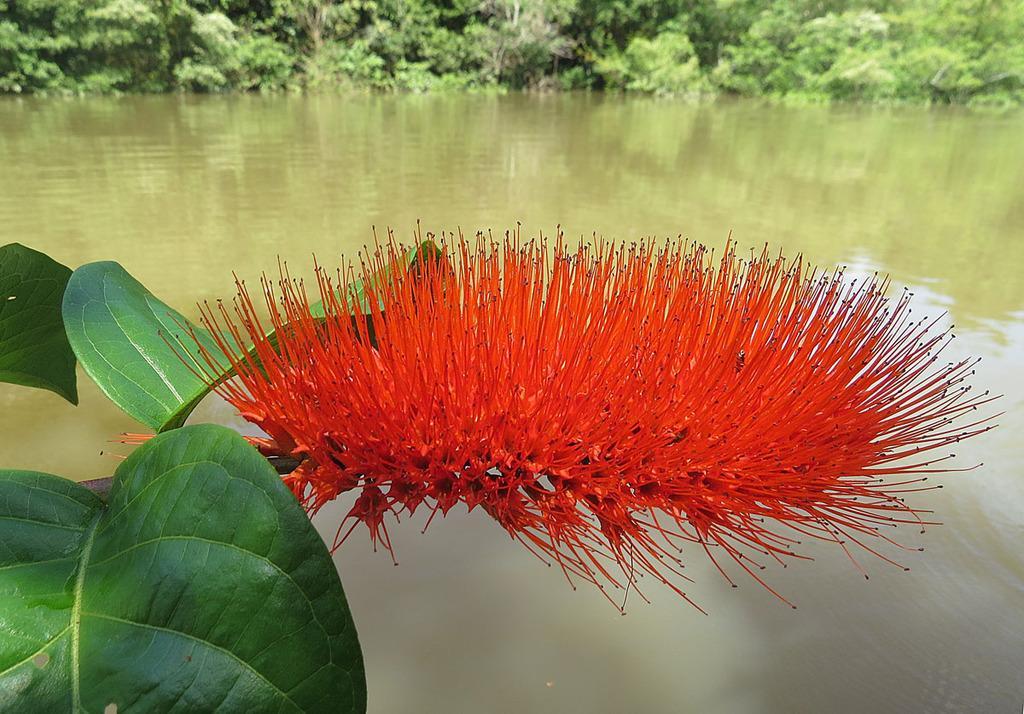In one or two sentences, can you explain what this image depicts? In this picture we can see flower, leaves and water. In the background of the image we can see trees. 